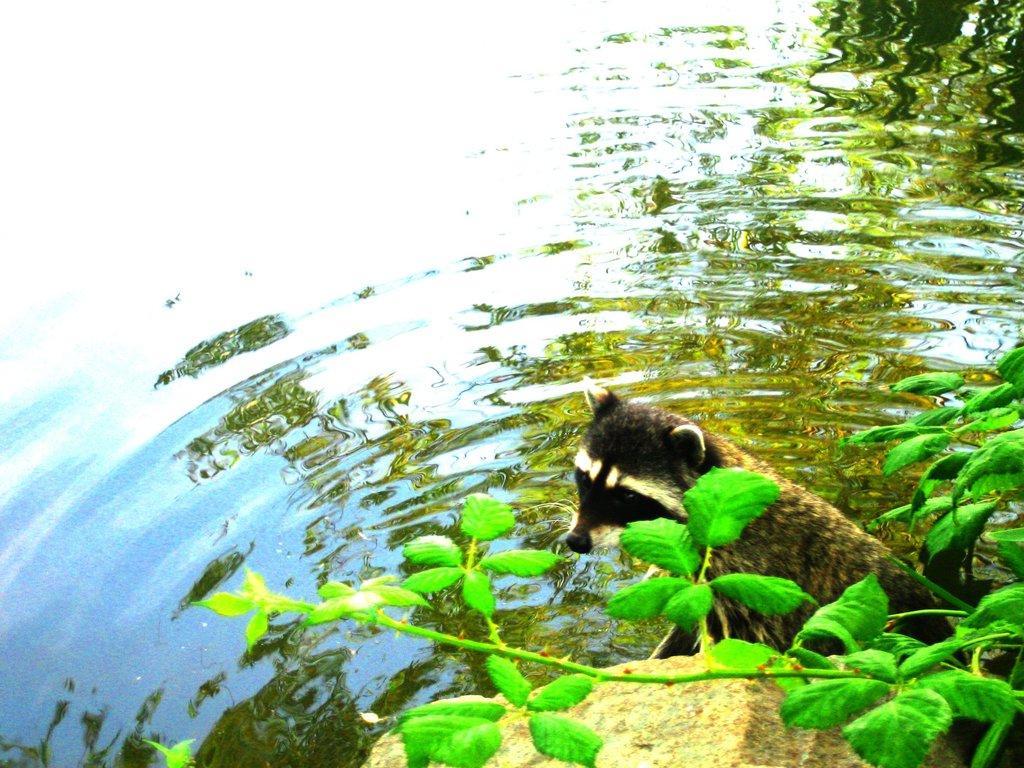In one or two sentences, can you explain what this image depicts? This is water and there is an animal. Here we can see planets and a stone. 